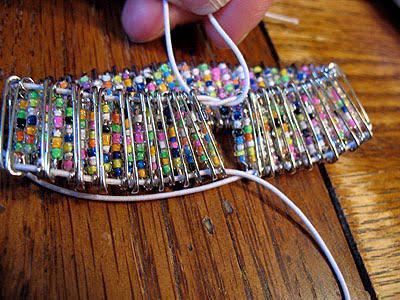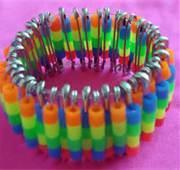The first image is the image on the left, the second image is the image on the right. For the images shown, is this caption "An image shows flat beaded items in geometric shapes." true? Answer yes or no. No. 